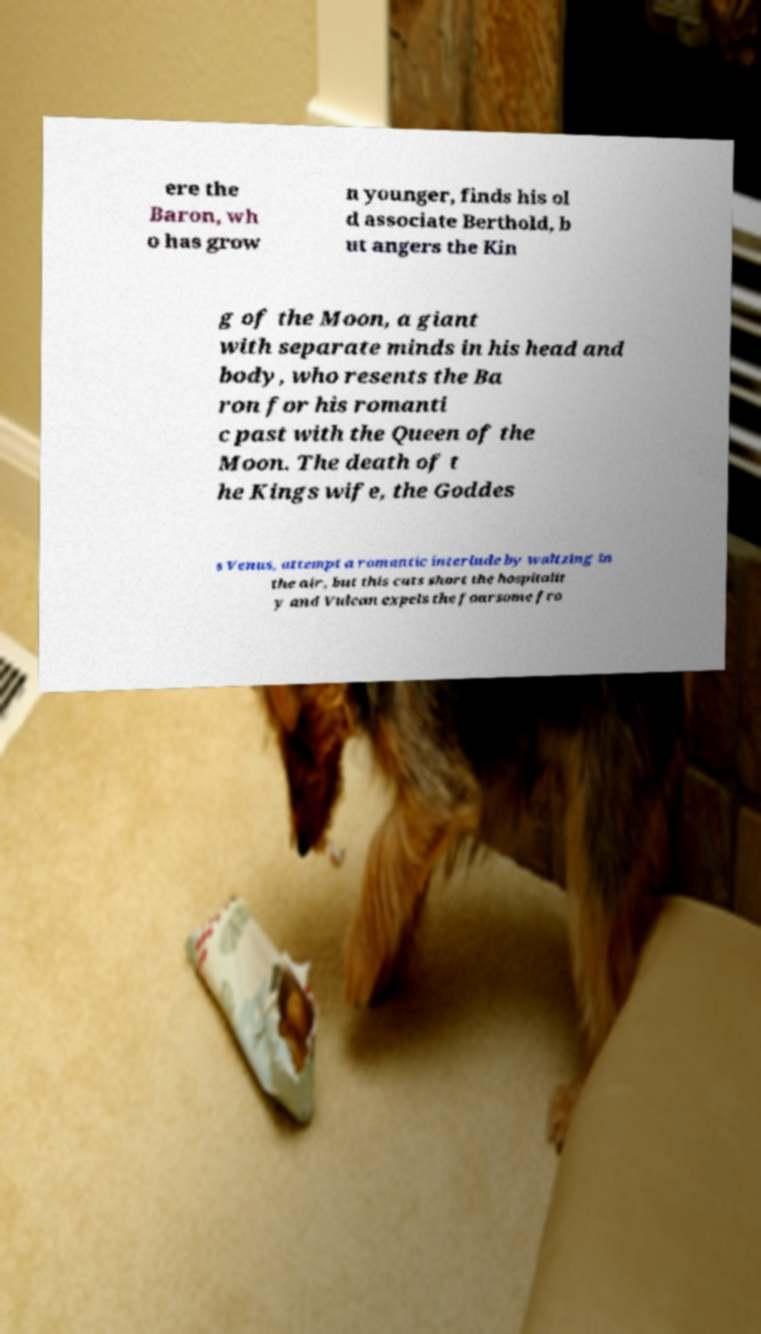There's text embedded in this image that I need extracted. Can you transcribe it verbatim? ere the Baron, wh o has grow n younger, finds his ol d associate Berthold, b ut angers the Kin g of the Moon, a giant with separate minds in his head and body, who resents the Ba ron for his romanti c past with the Queen of the Moon. The death of t he Kings wife, the Goddes s Venus, attempt a romantic interlude by waltzing in the air, but this cuts short the hospitalit y and Vulcan expels the foursome fro 